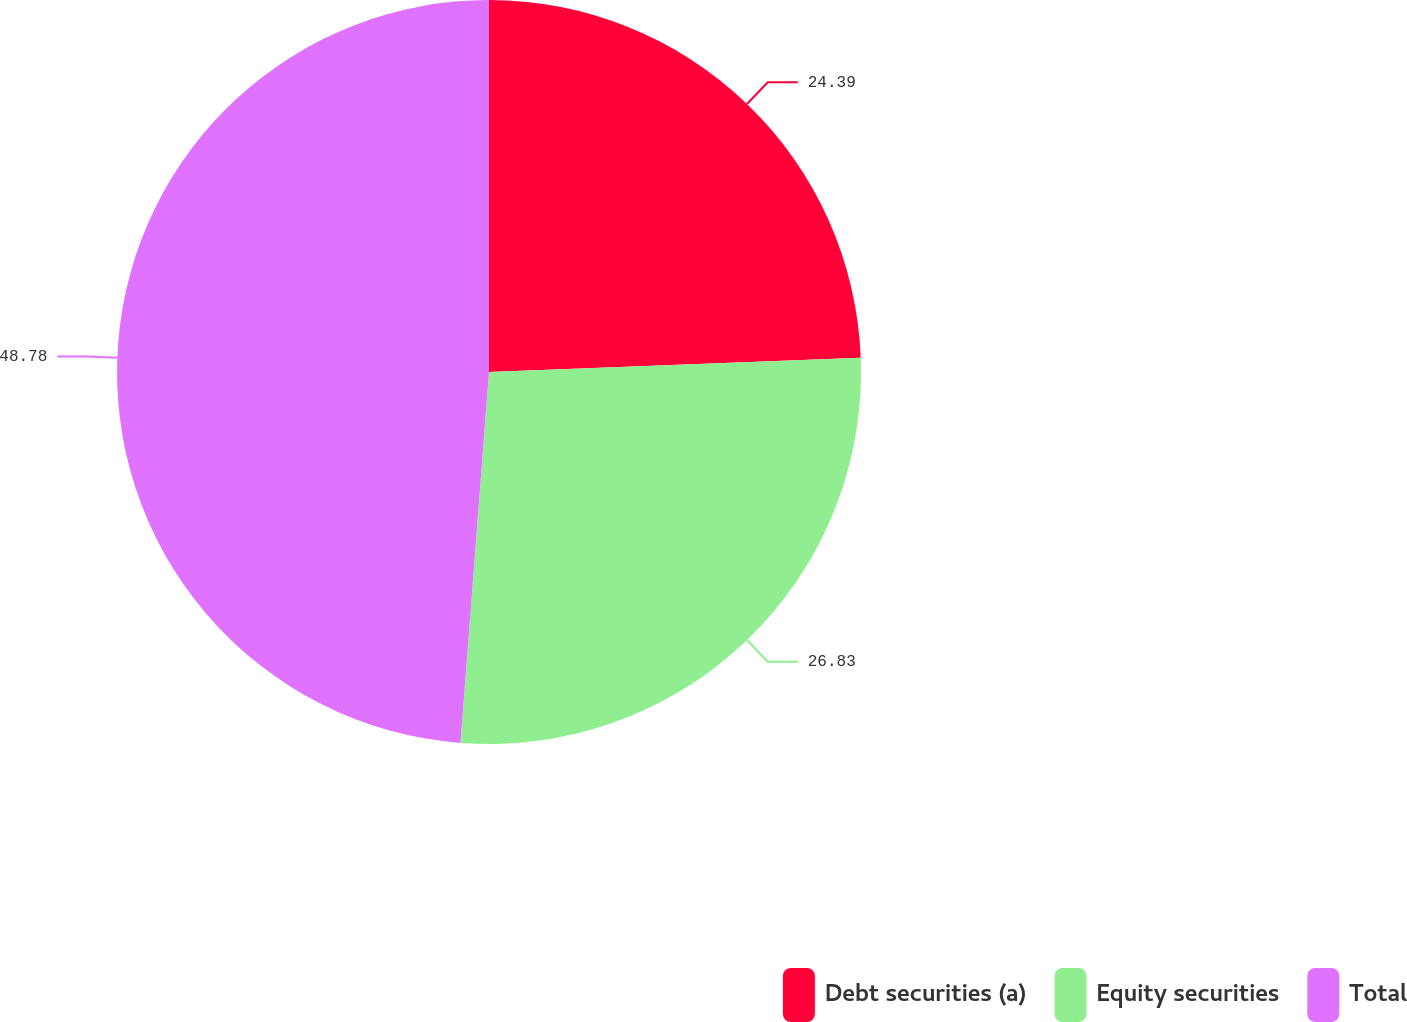<chart> <loc_0><loc_0><loc_500><loc_500><pie_chart><fcel>Debt securities (a)<fcel>Equity securities<fcel>Total<nl><fcel>24.39%<fcel>26.83%<fcel>48.78%<nl></chart> 